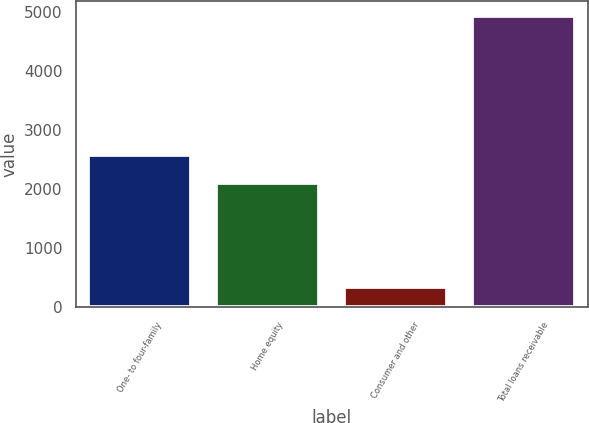Convert chart to OTSL. <chart><loc_0><loc_0><loc_500><loc_500><bar_chart><fcel>One- to four-family<fcel>Home equity<fcel>Consumer and other<fcel>Total loans receivable<nl><fcel>2574.2<fcel>2114<fcel>341<fcel>4943<nl></chart> 